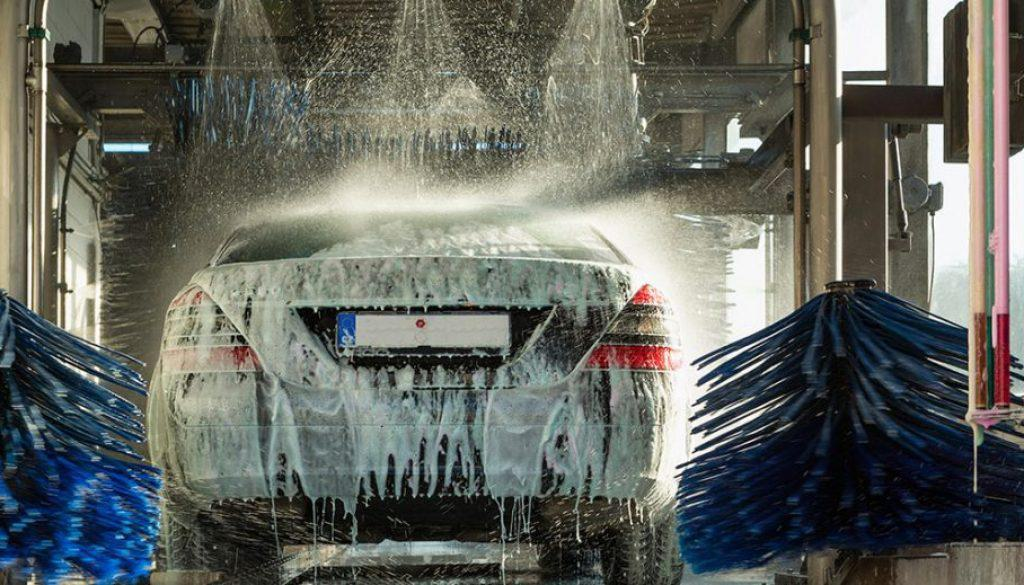What make and model does the car appear to be? While the image doesn't provide a full view of the car, based on the visible design features, it appears to be a luxury sedan. However, the exact make and model cannot be determined from this angle and with the soap covering. 